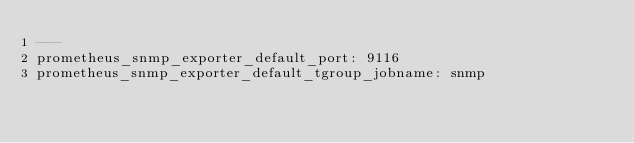<code> <loc_0><loc_0><loc_500><loc_500><_YAML_>---
prometheus_snmp_exporter_default_port: 9116
prometheus_snmp_exporter_default_tgroup_jobname: snmp
</code> 